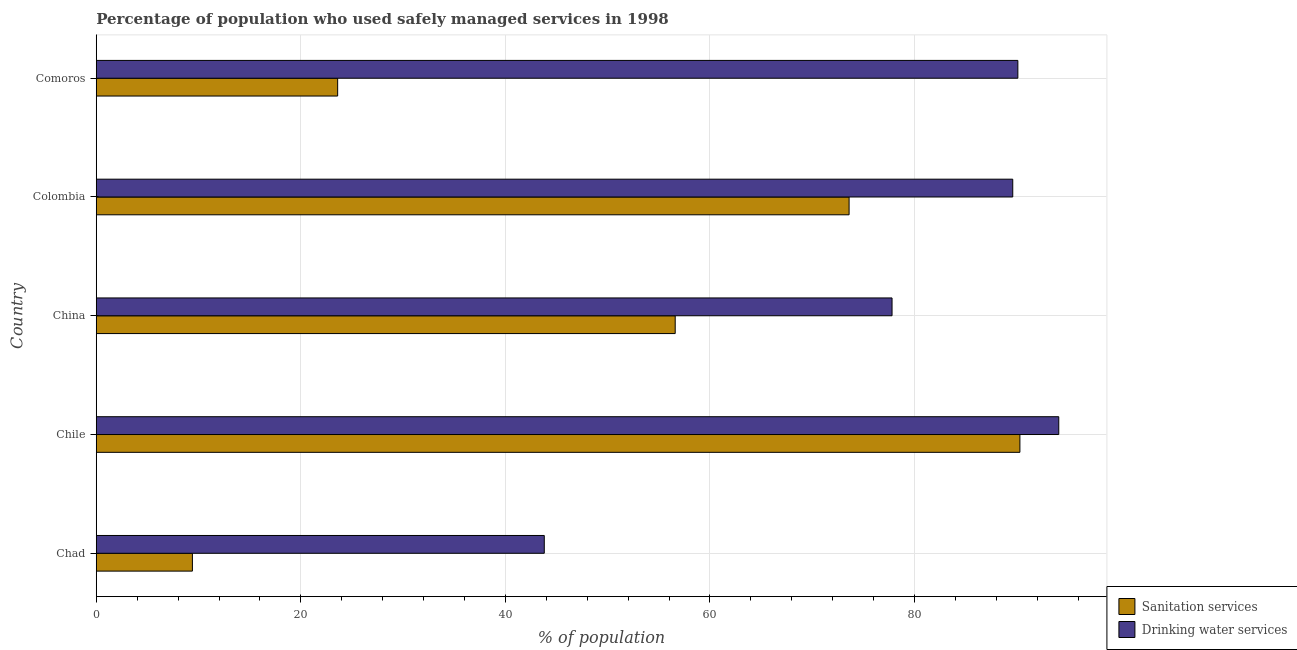How many groups of bars are there?
Your response must be concise. 5. How many bars are there on the 2nd tick from the top?
Keep it short and to the point. 2. How many bars are there on the 2nd tick from the bottom?
Your answer should be compact. 2. What is the label of the 1st group of bars from the top?
Your response must be concise. Comoros. What is the percentage of population who used sanitation services in Comoros?
Give a very brief answer. 23.6. Across all countries, what is the maximum percentage of population who used sanitation services?
Your answer should be compact. 90.3. Across all countries, what is the minimum percentage of population who used sanitation services?
Offer a terse response. 9.4. In which country was the percentage of population who used sanitation services minimum?
Your answer should be very brief. Chad. What is the total percentage of population who used drinking water services in the graph?
Your answer should be very brief. 395.4. What is the difference between the percentage of population who used sanitation services in China and the percentage of population who used drinking water services in Colombia?
Keep it short and to the point. -33. What is the average percentage of population who used drinking water services per country?
Make the answer very short. 79.08. What is the difference between the percentage of population who used drinking water services and percentage of population who used sanitation services in Chad?
Offer a very short reply. 34.4. What is the ratio of the percentage of population who used drinking water services in Chad to that in China?
Offer a very short reply. 0.56. Is the difference between the percentage of population who used drinking water services in Chile and Colombia greater than the difference between the percentage of population who used sanitation services in Chile and Colombia?
Give a very brief answer. No. What is the difference between the highest and the lowest percentage of population who used sanitation services?
Provide a succinct answer. 80.9. What does the 2nd bar from the top in Colombia represents?
Keep it short and to the point. Sanitation services. What does the 1st bar from the bottom in Chad represents?
Ensure brevity in your answer.  Sanitation services. How many bars are there?
Provide a short and direct response. 10. Are all the bars in the graph horizontal?
Give a very brief answer. Yes. What is the difference between two consecutive major ticks on the X-axis?
Provide a short and direct response. 20. Are the values on the major ticks of X-axis written in scientific E-notation?
Make the answer very short. No. Does the graph contain any zero values?
Ensure brevity in your answer.  No. How many legend labels are there?
Give a very brief answer. 2. How are the legend labels stacked?
Ensure brevity in your answer.  Vertical. What is the title of the graph?
Give a very brief answer. Percentage of population who used safely managed services in 1998. What is the label or title of the X-axis?
Provide a short and direct response. % of population. What is the % of population of Sanitation services in Chad?
Offer a terse response. 9.4. What is the % of population in Drinking water services in Chad?
Provide a short and direct response. 43.8. What is the % of population of Sanitation services in Chile?
Ensure brevity in your answer.  90.3. What is the % of population of Drinking water services in Chile?
Your answer should be very brief. 94.1. What is the % of population of Sanitation services in China?
Keep it short and to the point. 56.6. What is the % of population of Drinking water services in China?
Provide a succinct answer. 77.8. What is the % of population of Sanitation services in Colombia?
Ensure brevity in your answer.  73.6. What is the % of population of Drinking water services in Colombia?
Your response must be concise. 89.6. What is the % of population of Sanitation services in Comoros?
Offer a terse response. 23.6. What is the % of population of Drinking water services in Comoros?
Your answer should be very brief. 90.1. Across all countries, what is the maximum % of population of Sanitation services?
Your answer should be very brief. 90.3. Across all countries, what is the maximum % of population in Drinking water services?
Give a very brief answer. 94.1. Across all countries, what is the minimum % of population in Drinking water services?
Give a very brief answer. 43.8. What is the total % of population in Sanitation services in the graph?
Your answer should be very brief. 253.5. What is the total % of population in Drinking water services in the graph?
Make the answer very short. 395.4. What is the difference between the % of population of Sanitation services in Chad and that in Chile?
Your response must be concise. -80.9. What is the difference between the % of population in Drinking water services in Chad and that in Chile?
Offer a terse response. -50.3. What is the difference between the % of population of Sanitation services in Chad and that in China?
Give a very brief answer. -47.2. What is the difference between the % of population in Drinking water services in Chad and that in China?
Offer a very short reply. -34. What is the difference between the % of population of Sanitation services in Chad and that in Colombia?
Offer a terse response. -64.2. What is the difference between the % of population in Drinking water services in Chad and that in Colombia?
Your answer should be very brief. -45.8. What is the difference between the % of population of Sanitation services in Chad and that in Comoros?
Keep it short and to the point. -14.2. What is the difference between the % of population in Drinking water services in Chad and that in Comoros?
Offer a very short reply. -46.3. What is the difference between the % of population of Sanitation services in Chile and that in China?
Give a very brief answer. 33.7. What is the difference between the % of population in Drinking water services in Chile and that in China?
Offer a terse response. 16.3. What is the difference between the % of population of Sanitation services in Chile and that in Comoros?
Ensure brevity in your answer.  66.7. What is the difference between the % of population in Drinking water services in Chile and that in Comoros?
Your answer should be compact. 4. What is the difference between the % of population in Sanitation services in China and that in Colombia?
Ensure brevity in your answer.  -17. What is the difference between the % of population of Drinking water services in Colombia and that in Comoros?
Your answer should be compact. -0.5. What is the difference between the % of population in Sanitation services in Chad and the % of population in Drinking water services in Chile?
Ensure brevity in your answer.  -84.7. What is the difference between the % of population of Sanitation services in Chad and the % of population of Drinking water services in China?
Keep it short and to the point. -68.4. What is the difference between the % of population in Sanitation services in Chad and the % of population in Drinking water services in Colombia?
Your answer should be compact. -80.2. What is the difference between the % of population of Sanitation services in Chad and the % of population of Drinking water services in Comoros?
Make the answer very short. -80.7. What is the difference between the % of population of Sanitation services in Chile and the % of population of Drinking water services in Colombia?
Your answer should be very brief. 0.7. What is the difference between the % of population in Sanitation services in Chile and the % of population in Drinking water services in Comoros?
Your answer should be compact. 0.2. What is the difference between the % of population of Sanitation services in China and the % of population of Drinking water services in Colombia?
Ensure brevity in your answer.  -33. What is the difference between the % of population of Sanitation services in China and the % of population of Drinking water services in Comoros?
Provide a succinct answer. -33.5. What is the difference between the % of population of Sanitation services in Colombia and the % of population of Drinking water services in Comoros?
Make the answer very short. -16.5. What is the average % of population in Sanitation services per country?
Keep it short and to the point. 50.7. What is the average % of population of Drinking water services per country?
Offer a terse response. 79.08. What is the difference between the % of population of Sanitation services and % of population of Drinking water services in Chad?
Give a very brief answer. -34.4. What is the difference between the % of population in Sanitation services and % of population in Drinking water services in China?
Your response must be concise. -21.2. What is the difference between the % of population in Sanitation services and % of population in Drinking water services in Colombia?
Offer a terse response. -16. What is the difference between the % of population of Sanitation services and % of population of Drinking water services in Comoros?
Offer a very short reply. -66.5. What is the ratio of the % of population in Sanitation services in Chad to that in Chile?
Give a very brief answer. 0.1. What is the ratio of the % of population of Drinking water services in Chad to that in Chile?
Offer a terse response. 0.47. What is the ratio of the % of population in Sanitation services in Chad to that in China?
Keep it short and to the point. 0.17. What is the ratio of the % of population in Drinking water services in Chad to that in China?
Your answer should be compact. 0.56. What is the ratio of the % of population of Sanitation services in Chad to that in Colombia?
Provide a short and direct response. 0.13. What is the ratio of the % of population in Drinking water services in Chad to that in Colombia?
Make the answer very short. 0.49. What is the ratio of the % of population in Sanitation services in Chad to that in Comoros?
Offer a terse response. 0.4. What is the ratio of the % of population of Drinking water services in Chad to that in Comoros?
Your answer should be very brief. 0.49. What is the ratio of the % of population in Sanitation services in Chile to that in China?
Keep it short and to the point. 1.6. What is the ratio of the % of population of Drinking water services in Chile to that in China?
Your answer should be very brief. 1.21. What is the ratio of the % of population in Sanitation services in Chile to that in Colombia?
Provide a succinct answer. 1.23. What is the ratio of the % of population in Drinking water services in Chile to that in Colombia?
Offer a very short reply. 1.05. What is the ratio of the % of population of Sanitation services in Chile to that in Comoros?
Keep it short and to the point. 3.83. What is the ratio of the % of population of Drinking water services in Chile to that in Comoros?
Your answer should be very brief. 1.04. What is the ratio of the % of population in Sanitation services in China to that in Colombia?
Your response must be concise. 0.77. What is the ratio of the % of population of Drinking water services in China to that in Colombia?
Give a very brief answer. 0.87. What is the ratio of the % of population of Sanitation services in China to that in Comoros?
Keep it short and to the point. 2.4. What is the ratio of the % of population in Drinking water services in China to that in Comoros?
Ensure brevity in your answer.  0.86. What is the ratio of the % of population of Sanitation services in Colombia to that in Comoros?
Provide a short and direct response. 3.12. What is the ratio of the % of population in Drinking water services in Colombia to that in Comoros?
Your response must be concise. 0.99. What is the difference between the highest and the second highest % of population of Sanitation services?
Your response must be concise. 16.7. What is the difference between the highest and the lowest % of population of Sanitation services?
Give a very brief answer. 80.9. What is the difference between the highest and the lowest % of population of Drinking water services?
Provide a short and direct response. 50.3. 